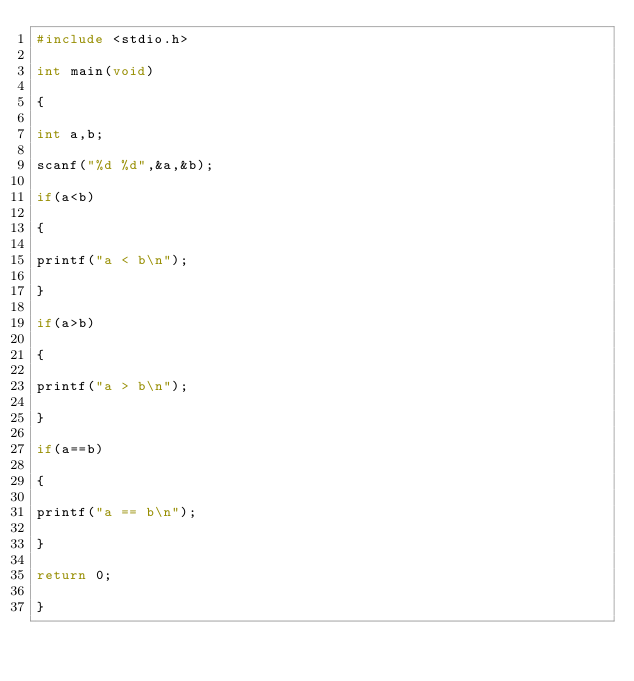<code> <loc_0><loc_0><loc_500><loc_500><_C_>#include <stdio.h>
 
int main(void)
 
{
 
int a,b;
 
scanf("%d %d",&a,&b);
 
if(a<b)
 
{
 
printf("a < b\n");
 
}
 
if(a>b)
 
{
 
printf("a > b\n");
 
}
 
if(a==b)
 
{
 
printf("a == b\n");
 
}
 
return 0;
 
}</code> 